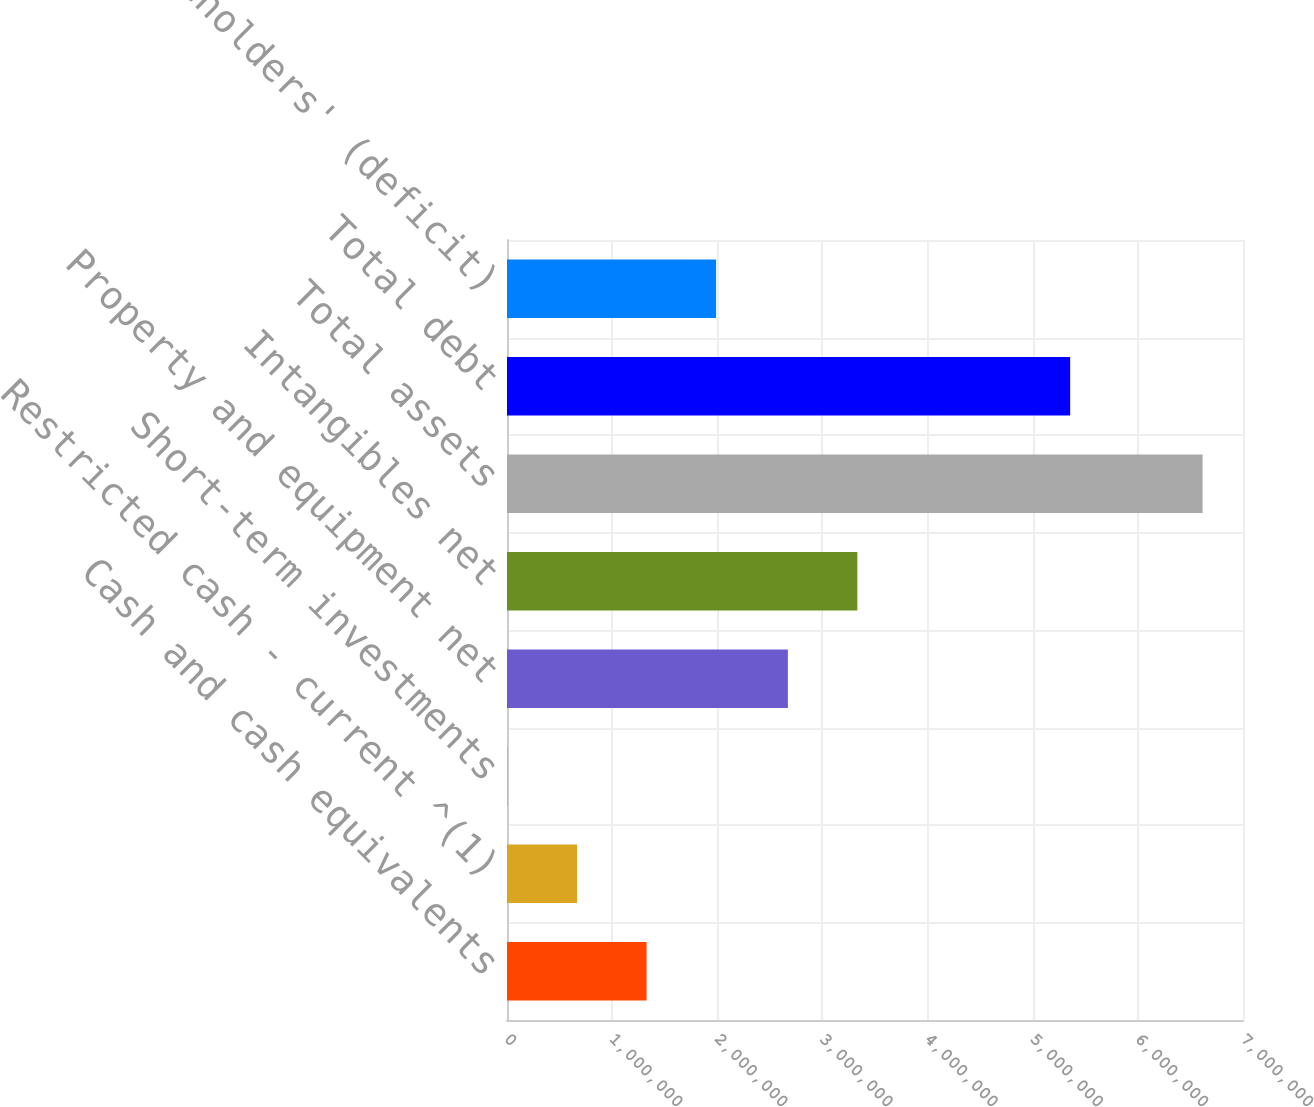Convert chart to OTSL. <chart><loc_0><loc_0><loc_500><loc_500><bar_chart><fcel>Cash and cash equivalents<fcel>Restricted cash - current ^(1)<fcel>Short-term investments<fcel>Property and equipment net<fcel>Intangibles net<fcel>Total assets<fcel>Total debt<fcel>Total shareholders' (deficit)<nl><fcel>1.32756e+06<fcel>666515<fcel>5471<fcel>2.67132e+06<fcel>3.33236e+06<fcel>6.61591e+06<fcel>5.3561e+06<fcel>1.9886e+06<nl></chart> 